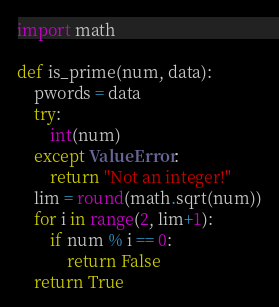<code> <loc_0><loc_0><loc_500><loc_500><_Python_>import math

def is_prime(num, data):
    pwords = data
    try:
        int(num)
    except ValueError:
        return "Not an integer!"
    lim = round(math.sqrt(num))
    for i in range(2, lim+1):
        if num % i == 0:
            return False
    return True
</code> 